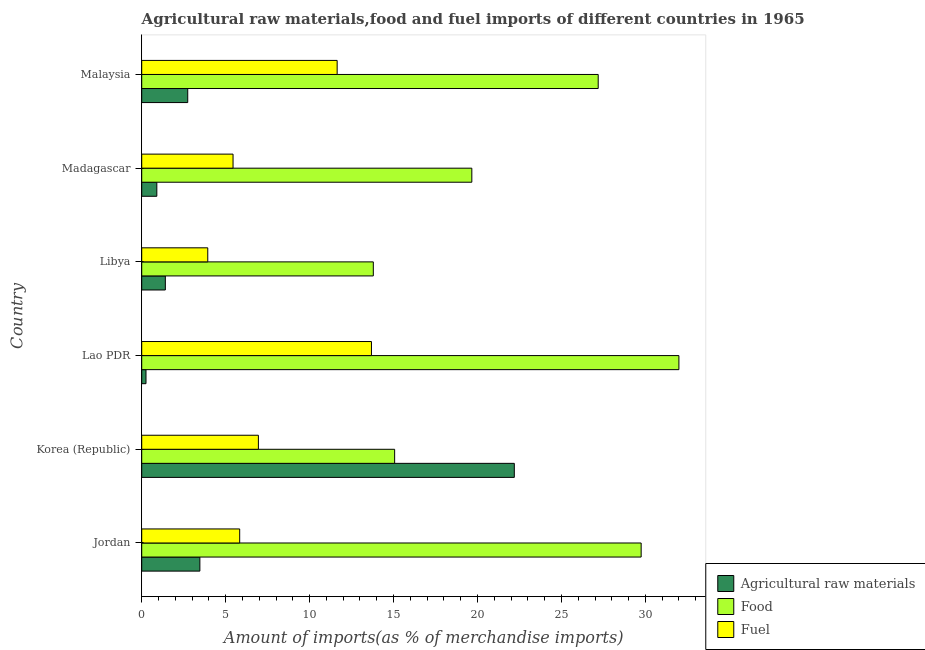How many groups of bars are there?
Ensure brevity in your answer.  6. Are the number of bars per tick equal to the number of legend labels?
Your answer should be very brief. Yes. How many bars are there on the 5th tick from the bottom?
Keep it short and to the point. 3. What is the label of the 3rd group of bars from the top?
Provide a short and direct response. Libya. In how many cases, is the number of bars for a given country not equal to the number of legend labels?
Your response must be concise. 0. What is the percentage of fuel imports in Malaysia?
Your answer should be compact. 11.64. Across all countries, what is the maximum percentage of food imports?
Your answer should be compact. 32. Across all countries, what is the minimum percentage of raw materials imports?
Your answer should be compact. 0.25. In which country was the percentage of food imports maximum?
Keep it short and to the point. Lao PDR. In which country was the percentage of fuel imports minimum?
Ensure brevity in your answer.  Libya. What is the total percentage of fuel imports in the graph?
Keep it short and to the point. 47.48. What is the difference between the percentage of food imports in Jordan and that in Madagascar?
Offer a terse response. 10.09. What is the difference between the percentage of food imports in Madagascar and the percentage of fuel imports in Jordan?
Make the answer very short. 13.83. What is the average percentage of raw materials imports per country?
Provide a succinct answer. 5.16. What is the difference between the percentage of fuel imports and percentage of food imports in Lao PDR?
Provide a short and direct response. -18.31. In how many countries, is the percentage of fuel imports greater than 31 %?
Your response must be concise. 0. What is the ratio of the percentage of food imports in Jordan to that in Korea (Republic)?
Offer a terse response. 1.98. Is the percentage of fuel imports in Madagascar less than that in Malaysia?
Your response must be concise. Yes. What is the difference between the highest and the second highest percentage of raw materials imports?
Offer a very short reply. 18.73. What does the 3rd bar from the top in Madagascar represents?
Provide a succinct answer. Agricultural raw materials. What does the 3rd bar from the bottom in Korea (Republic) represents?
Offer a very short reply. Fuel. Are all the bars in the graph horizontal?
Your answer should be very brief. Yes. What is the difference between two consecutive major ticks on the X-axis?
Provide a succinct answer. 5. Does the graph contain grids?
Keep it short and to the point. No. How many legend labels are there?
Offer a terse response. 3. What is the title of the graph?
Provide a succinct answer. Agricultural raw materials,food and fuel imports of different countries in 1965. What is the label or title of the X-axis?
Provide a short and direct response. Amount of imports(as % of merchandise imports). What is the label or title of the Y-axis?
Make the answer very short. Country. What is the Amount of imports(as % of merchandise imports) of Agricultural raw materials in Jordan?
Ensure brevity in your answer.  3.46. What is the Amount of imports(as % of merchandise imports) in Food in Jordan?
Ensure brevity in your answer.  29.75. What is the Amount of imports(as % of merchandise imports) in Fuel in Jordan?
Make the answer very short. 5.83. What is the Amount of imports(as % of merchandise imports) of Agricultural raw materials in Korea (Republic)?
Give a very brief answer. 22.19. What is the Amount of imports(as % of merchandise imports) of Food in Korea (Republic)?
Keep it short and to the point. 15.06. What is the Amount of imports(as % of merchandise imports) in Fuel in Korea (Republic)?
Offer a very short reply. 6.95. What is the Amount of imports(as % of merchandise imports) in Agricultural raw materials in Lao PDR?
Provide a short and direct response. 0.25. What is the Amount of imports(as % of merchandise imports) of Food in Lao PDR?
Keep it short and to the point. 32. What is the Amount of imports(as % of merchandise imports) of Fuel in Lao PDR?
Offer a terse response. 13.68. What is the Amount of imports(as % of merchandise imports) of Agricultural raw materials in Libya?
Make the answer very short. 1.41. What is the Amount of imports(as % of merchandise imports) of Food in Libya?
Offer a very short reply. 13.79. What is the Amount of imports(as % of merchandise imports) in Fuel in Libya?
Offer a very short reply. 3.93. What is the Amount of imports(as % of merchandise imports) of Agricultural raw materials in Madagascar?
Offer a very short reply. 0.9. What is the Amount of imports(as % of merchandise imports) in Food in Madagascar?
Offer a terse response. 19.66. What is the Amount of imports(as % of merchandise imports) in Fuel in Madagascar?
Your answer should be very brief. 5.44. What is the Amount of imports(as % of merchandise imports) of Agricultural raw materials in Malaysia?
Give a very brief answer. 2.74. What is the Amount of imports(as % of merchandise imports) of Food in Malaysia?
Your response must be concise. 27.19. What is the Amount of imports(as % of merchandise imports) in Fuel in Malaysia?
Ensure brevity in your answer.  11.64. Across all countries, what is the maximum Amount of imports(as % of merchandise imports) in Agricultural raw materials?
Offer a terse response. 22.19. Across all countries, what is the maximum Amount of imports(as % of merchandise imports) of Food?
Provide a succinct answer. 32. Across all countries, what is the maximum Amount of imports(as % of merchandise imports) in Fuel?
Your answer should be compact. 13.68. Across all countries, what is the minimum Amount of imports(as % of merchandise imports) of Agricultural raw materials?
Offer a very short reply. 0.25. Across all countries, what is the minimum Amount of imports(as % of merchandise imports) in Food?
Make the answer very short. 13.79. Across all countries, what is the minimum Amount of imports(as % of merchandise imports) of Fuel?
Make the answer very short. 3.93. What is the total Amount of imports(as % of merchandise imports) in Agricultural raw materials in the graph?
Provide a succinct answer. 30.96. What is the total Amount of imports(as % of merchandise imports) of Food in the graph?
Your answer should be very brief. 137.46. What is the total Amount of imports(as % of merchandise imports) in Fuel in the graph?
Make the answer very short. 47.48. What is the difference between the Amount of imports(as % of merchandise imports) in Agricultural raw materials in Jordan and that in Korea (Republic)?
Offer a terse response. -18.73. What is the difference between the Amount of imports(as % of merchandise imports) in Food in Jordan and that in Korea (Republic)?
Your answer should be compact. 14.68. What is the difference between the Amount of imports(as % of merchandise imports) in Fuel in Jordan and that in Korea (Republic)?
Ensure brevity in your answer.  -1.11. What is the difference between the Amount of imports(as % of merchandise imports) in Agricultural raw materials in Jordan and that in Lao PDR?
Offer a very short reply. 3.21. What is the difference between the Amount of imports(as % of merchandise imports) of Food in Jordan and that in Lao PDR?
Keep it short and to the point. -2.25. What is the difference between the Amount of imports(as % of merchandise imports) of Fuel in Jordan and that in Lao PDR?
Your answer should be compact. -7.85. What is the difference between the Amount of imports(as % of merchandise imports) of Agricultural raw materials in Jordan and that in Libya?
Offer a very short reply. 2.06. What is the difference between the Amount of imports(as % of merchandise imports) in Food in Jordan and that in Libya?
Provide a short and direct response. 15.95. What is the difference between the Amount of imports(as % of merchandise imports) in Fuel in Jordan and that in Libya?
Offer a very short reply. 1.9. What is the difference between the Amount of imports(as % of merchandise imports) of Agricultural raw materials in Jordan and that in Madagascar?
Ensure brevity in your answer.  2.56. What is the difference between the Amount of imports(as % of merchandise imports) in Food in Jordan and that in Madagascar?
Make the answer very short. 10.09. What is the difference between the Amount of imports(as % of merchandise imports) of Fuel in Jordan and that in Madagascar?
Keep it short and to the point. 0.4. What is the difference between the Amount of imports(as % of merchandise imports) of Agricultural raw materials in Jordan and that in Malaysia?
Your answer should be compact. 0.72. What is the difference between the Amount of imports(as % of merchandise imports) in Food in Jordan and that in Malaysia?
Give a very brief answer. 2.56. What is the difference between the Amount of imports(as % of merchandise imports) in Fuel in Jordan and that in Malaysia?
Offer a very short reply. -5.81. What is the difference between the Amount of imports(as % of merchandise imports) in Agricultural raw materials in Korea (Republic) and that in Lao PDR?
Your response must be concise. 21.94. What is the difference between the Amount of imports(as % of merchandise imports) of Food in Korea (Republic) and that in Lao PDR?
Ensure brevity in your answer.  -16.93. What is the difference between the Amount of imports(as % of merchandise imports) of Fuel in Korea (Republic) and that in Lao PDR?
Offer a terse response. -6.73. What is the difference between the Amount of imports(as % of merchandise imports) of Agricultural raw materials in Korea (Republic) and that in Libya?
Make the answer very short. 20.79. What is the difference between the Amount of imports(as % of merchandise imports) of Food in Korea (Republic) and that in Libya?
Your response must be concise. 1.27. What is the difference between the Amount of imports(as % of merchandise imports) of Fuel in Korea (Republic) and that in Libya?
Your response must be concise. 3.02. What is the difference between the Amount of imports(as % of merchandise imports) in Agricultural raw materials in Korea (Republic) and that in Madagascar?
Give a very brief answer. 21.29. What is the difference between the Amount of imports(as % of merchandise imports) of Food in Korea (Republic) and that in Madagascar?
Give a very brief answer. -4.6. What is the difference between the Amount of imports(as % of merchandise imports) of Fuel in Korea (Republic) and that in Madagascar?
Give a very brief answer. 1.51. What is the difference between the Amount of imports(as % of merchandise imports) in Agricultural raw materials in Korea (Republic) and that in Malaysia?
Keep it short and to the point. 19.45. What is the difference between the Amount of imports(as % of merchandise imports) in Food in Korea (Republic) and that in Malaysia?
Provide a short and direct response. -12.13. What is the difference between the Amount of imports(as % of merchandise imports) in Fuel in Korea (Republic) and that in Malaysia?
Offer a terse response. -4.69. What is the difference between the Amount of imports(as % of merchandise imports) of Agricultural raw materials in Lao PDR and that in Libya?
Keep it short and to the point. -1.15. What is the difference between the Amount of imports(as % of merchandise imports) in Food in Lao PDR and that in Libya?
Make the answer very short. 18.2. What is the difference between the Amount of imports(as % of merchandise imports) in Fuel in Lao PDR and that in Libya?
Ensure brevity in your answer.  9.75. What is the difference between the Amount of imports(as % of merchandise imports) of Agricultural raw materials in Lao PDR and that in Madagascar?
Provide a succinct answer. -0.64. What is the difference between the Amount of imports(as % of merchandise imports) in Food in Lao PDR and that in Madagascar?
Give a very brief answer. 12.33. What is the difference between the Amount of imports(as % of merchandise imports) of Fuel in Lao PDR and that in Madagascar?
Keep it short and to the point. 8.24. What is the difference between the Amount of imports(as % of merchandise imports) of Agricultural raw materials in Lao PDR and that in Malaysia?
Your response must be concise. -2.49. What is the difference between the Amount of imports(as % of merchandise imports) in Food in Lao PDR and that in Malaysia?
Your answer should be very brief. 4.81. What is the difference between the Amount of imports(as % of merchandise imports) of Fuel in Lao PDR and that in Malaysia?
Give a very brief answer. 2.04. What is the difference between the Amount of imports(as % of merchandise imports) in Agricultural raw materials in Libya and that in Madagascar?
Offer a terse response. 0.51. What is the difference between the Amount of imports(as % of merchandise imports) in Food in Libya and that in Madagascar?
Offer a terse response. -5.87. What is the difference between the Amount of imports(as % of merchandise imports) of Fuel in Libya and that in Madagascar?
Your response must be concise. -1.51. What is the difference between the Amount of imports(as % of merchandise imports) of Agricultural raw materials in Libya and that in Malaysia?
Your response must be concise. -1.33. What is the difference between the Amount of imports(as % of merchandise imports) in Food in Libya and that in Malaysia?
Offer a terse response. -13.4. What is the difference between the Amount of imports(as % of merchandise imports) of Fuel in Libya and that in Malaysia?
Make the answer very short. -7.71. What is the difference between the Amount of imports(as % of merchandise imports) in Agricultural raw materials in Madagascar and that in Malaysia?
Provide a short and direct response. -1.84. What is the difference between the Amount of imports(as % of merchandise imports) of Food in Madagascar and that in Malaysia?
Keep it short and to the point. -7.53. What is the difference between the Amount of imports(as % of merchandise imports) of Fuel in Madagascar and that in Malaysia?
Offer a very short reply. -6.2. What is the difference between the Amount of imports(as % of merchandise imports) of Agricultural raw materials in Jordan and the Amount of imports(as % of merchandise imports) of Food in Korea (Republic)?
Keep it short and to the point. -11.6. What is the difference between the Amount of imports(as % of merchandise imports) of Agricultural raw materials in Jordan and the Amount of imports(as % of merchandise imports) of Fuel in Korea (Republic)?
Your answer should be very brief. -3.49. What is the difference between the Amount of imports(as % of merchandise imports) in Food in Jordan and the Amount of imports(as % of merchandise imports) in Fuel in Korea (Republic)?
Give a very brief answer. 22.8. What is the difference between the Amount of imports(as % of merchandise imports) of Agricultural raw materials in Jordan and the Amount of imports(as % of merchandise imports) of Food in Lao PDR?
Your answer should be compact. -28.53. What is the difference between the Amount of imports(as % of merchandise imports) of Agricultural raw materials in Jordan and the Amount of imports(as % of merchandise imports) of Fuel in Lao PDR?
Your answer should be compact. -10.22. What is the difference between the Amount of imports(as % of merchandise imports) of Food in Jordan and the Amount of imports(as % of merchandise imports) of Fuel in Lao PDR?
Offer a very short reply. 16.06. What is the difference between the Amount of imports(as % of merchandise imports) in Agricultural raw materials in Jordan and the Amount of imports(as % of merchandise imports) in Food in Libya?
Ensure brevity in your answer.  -10.33. What is the difference between the Amount of imports(as % of merchandise imports) of Agricultural raw materials in Jordan and the Amount of imports(as % of merchandise imports) of Fuel in Libya?
Make the answer very short. -0.47. What is the difference between the Amount of imports(as % of merchandise imports) in Food in Jordan and the Amount of imports(as % of merchandise imports) in Fuel in Libya?
Provide a short and direct response. 25.81. What is the difference between the Amount of imports(as % of merchandise imports) of Agricultural raw materials in Jordan and the Amount of imports(as % of merchandise imports) of Food in Madagascar?
Make the answer very short. -16.2. What is the difference between the Amount of imports(as % of merchandise imports) in Agricultural raw materials in Jordan and the Amount of imports(as % of merchandise imports) in Fuel in Madagascar?
Offer a terse response. -1.98. What is the difference between the Amount of imports(as % of merchandise imports) of Food in Jordan and the Amount of imports(as % of merchandise imports) of Fuel in Madagascar?
Provide a short and direct response. 24.31. What is the difference between the Amount of imports(as % of merchandise imports) of Agricultural raw materials in Jordan and the Amount of imports(as % of merchandise imports) of Food in Malaysia?
Keep it short and to the point. -23.73. What is the difference between the Amount of imports(as % of merchandise imports) of Agricultural raw materials in Jordan and the Amount of imports(as % of merchandise imports) of Fuel in Malaysia?
Your answer should be very brief. -8.18. What is the difference between the Amount of imports(as % of merchandise imports) of Food in Jordan and the Amount of imports(as % of merchandise imports) of Fuel in Malaysia?
Give a very brief answer. 18.11. What is the difference between the Amount of imports(as % of merchandise imports) of Agricultural raw materials in Korea (Republic) and the Amount of imports(as % of merchandise imports) of Food in Lao PDR?
Your answer should be very brief. -9.8. What is the difference between the Amount of imports(as % of merchandise imports) in Agricultural raw materials in Korea (Republic) and the Amount of imports(as % of merchandise imports) in Fuel in Lao PDR?
Keep it short and to the point. 8.51. What is the difference between the Amount of imports(as % of merchandise imports) of Food in Korea (Republic) and the Amount of imports(as % of merchandise imports) of Fuel in Lao PDR?
Offer a terse response. 1.38. What is the difference between the Amount of imports(as % of merchandise imports) in Agricultural raw materials in Korea (Republic) and the Amount of imports(as % of merchandise imports) in Food in Libya?
Ensure brevity in your answer.  8.4. What is the difference between the Amount of imports(as % of merchandise imports) in Agricultural raw materials in Korea (Republic) and the Amount of imports(as % of merchandise imports) in Fuel in Libya?
Make the answer very short. 18.26. What is the difference between the Amount of imports(as % of merchandise imports) of Food in Korea (Republic) and the Amount of imports(as % of merchandise imports) of Fuel in Libya?
Ensure brevity in your answer.  11.13. What is the difference between the Amount of imports(as % of merchandise imports) of Agricultural raw materials in Korea (Republic) and the Amount of imports(as % of merchandise imports) of Food in Madagascar?
Your response must be concise. 2.53. What is the difference between the Amount of imports(as % of merchandise imports) of Agricultural raw materials in Korea (Republic) and the Amount of imports(as % of merchandise imports) of Fuel in Madagascar?
Your response must be concise. 16.75. What is the difference between the Amount of imports(as % of merchandise imports) in Food in Korea (Republic) and the Amount of imports(as % of merchandise imports) in Fuel in Madagascar?
Provide a short and direct response. 9.63. What is the difference between the Amount of imports(as % of merchandise imports) in Agricultural raw materials in Korea (Republic) and the Amount of imports(as % of merchandise imports) in Food in Malaysia?
Give a very brief answer. -5. What is the difference between the Amount of imports(as % of merchandise imports) of Agricultural raw materials in Korea (Republic) and the Amount of imports(as % of merchandise imports) of Fuel in Malaysia?
Ensure brevity in your answer.  10.55. What is the difference between the Amount of imports(as % of merchandise imports) of Food in Korea (Republic) and the Amount of imports(as % of merchandise imports) of Fuel in Malaysia?
Make the answer very short. 3.42. What is the difference between the Amount of imports(as % of merchandise imports) in Agricultural raw materials in Lao PDR and the Amount of imports(as % of merchandise imports) in Food in Libya?
Your response must be concise. -13.54. What is the difference between the Amount of imports(as % of merchandise imports) of Agricultural raw materials in Lao PDR and the Amount of imports(as % of merchandise imports) of Fuel in Libya?
Offer a very short reply. -3.68. What is the difference between the Amount of imports(as % of merchandise imports) of Food in Lao PDR and the Amount of imports(as % of merchandise imports) of Fuel in Libya?
Keep it short and to the point. 28.06. What is the difference between the Amount of imports(as % of merchandise imports) in Agricultural raw materials in Lao PDR and the Amount of imports(as % of merchandise imports) in Food in Madagascar?
Your answer should be compact. -19.41. What is the difference between the Amount of imports(as % of merchandise imports) in Agricultural raw materials in Lao PDR and the Amount of imports(as % of merchandise imports) in Fuel in Madagascar?
Your answer should be compact. -5.18. What is the difference between the Amount of imports(as % of merchandise imports) of Food in Lao PDR and the Amount of imports(as % of merchandise imports) of Fuel in Madagascar?
Keep it short and to the point. 26.56. What is the difference between the Amount of imports(as % of merchandise imports) of Agricultural raw materials in Lao PDR and the Amount of imports(as % of merchandise imports) of Food in Malaysia?
Your answer should be very brief. -26.93. What is the difference between the Amount of imports(as % of merchandise imports) of Agricultural raw materials in Lao PDR and the Amount of imports(as % of merchandise imports) of Fuel in Malaysia?
Provide a short and direct response. -11.39. What is the difference between the Amount of imports(as % of merchandise imports) in Food in Lao PDR and the Amount of imports(as % of merchandise imports) in Fuel in Malaysia?
Your response must be concise. 20.36. What is the difference between the Amount of imports(as % of merchandise imports) of Agricultural raw materials in Libya and the Amount of imports(as % of merchandise imports) of Food in Madagascar?
Keep it short and to the point. -18.26. What is the difference between the Amount of imports(as % of merchandise imports) in Agricultural raw materials in Libya and the Amount of imports(as % of merchandise imports) in Fuel in Madagascar?
Make the answer very short. -4.03. What is the difference between the Amount of imports(as % of merchandise imports) in Food in Libya and the Amount of imports(as % of merchandise imports) in Fuel in Madagascar?
Your response must be concise. 8.35. What is the difference between the Amount of imports(as % of merchandise imports) in Agricultural raw materials in Libya and the Amount of imports(as % of merchandise imports) in Food in Malaysia?
Ensure brevity in your answer.  -25.78. What is the difference between the Amount of imports(as % of merchandise imports) in Agricultural raw materials in Libya and the Amount of imports(as % of merchandise imports) in Fuel in Malaysia?
Make the answer very short. -10.23. What is the difference between the Amount of imports(as % of merchandise imports) in Food in Libya and the Amount of imports(as % of merchandise imports) in Fuel in Malaysia?
Make the answer very short. 2.15. What is the difference between the Amount of imports(as % of merchandise imports) in Agricultural raw materials in Madagascar and the Amount of imports(as % of merchandise imports) in Food in Malaysia?
Provide a short and direct response. -26.29. What is the difference between the Amount of imports(as % of merchandise imports) of Agricultural raw materials in Madagascar and the Amount of imports(as % of merchandise imports) of Fuel in Malaysia?
Provide a short and direct response. -10.74. What is the difference between the Amount of imports(as % of merchandise imports) in Food in Madagascar and the Amount of imports(as % of merchandise imports) in Fuel in Malaysia?
Make the answer very short. 8.02. What is the average Amount of imports(as % of merchandise imports) of Agricultural raw materials per country?
Offer a very short reply. 5.16. What is the average Amount of imports(as % of merchandise imports) in Food per country?
Provide a succinct answer. 22.91. What is the average Amount of imports(as % of merchandise imports) in Fuel per country?
Make the answer very short. 7.91. What is the difference between the Amount of imports(as % of merchandise imports) of Agricultural raw materials and Amount of imports(as % of merchandise imports) of Food in Jordan?
Ensure brevity in your answer.  -26.28. What is the difference between the Amount of imports(as % of merchandise imports) of Agricultural raw materials and Amount of imports(as % of merchandise imports) of Fuel in Jordan?
Offer a terse response. -2.37. What is the difference between the Amount of imports(as % of merchandise imports) in Food and Amount of imports(as % of merchandise imports) in Fuel in Jordan?
Offer a very short reply. 23.91. What is the difference between the Amount of imports(as % of merchandise imports) in Agricultural raw materials and Amount of imports(as % of merchandise imports) in Food in Korea (Republic)?
Give a very brief answer. 7.13. What is the difference between the Amount of imports(as % of merchandise imports) in Agricultural raw materials and Amount of imports(as % of merchandise imports) in Fuel in Korea (Republic)?
Your response must be concise. 15.24. What is the difference between the Amount of imports(as % of merchandise imports) in Food and Amount of imports(as % of merchandise imports) in Fuel in Korea (Republic)?
Your answer should be compact. 8.12. What is the difference between the Amount of imports(as % of merchandise imports) of Agricultural raw materials and Amount of imports(as % of merchandise imports) of Food in Lao PDR?
Offer a terse response. -31.74. What is the difference between the Amount of imports(as % of merchandise imports) of Agricultural raw materials and Amount of imports(as % of merchandise imports) of Fuel in Lao PDR?
Your answer should be very brief. -13.43. What is the difference between the Amount of imports(as % of merchandise imports) in Food and Amount of imports(as % of merchandise imports) in Fuel in Lao PDR?
Offer a terse response. 18.31. What is the difference between the Amount of imports(as % of merchandise imports) in Agricultural raw materials and Amount of imports(as % of merchandise imports) in Food in Libya?
Offer a very short reply. -12.39. What is the difference between the Amount of imports(as % of merchandise imports) of Agricultural raw materials and Amount of imports(as % of merchandise imports) of Fuel in Libya?
Offer a terse response. -2.53. What is the difference between the Amount of imports(as % of merchandise imports) in Food and Amount of imports(as % of merchandise imports) in Fuel in Libya?
Make the answer very short. 9.86. What is the difference between the Amount of imports(as % of merchandise imports) of Agricultural raw materials and Amount of imports(as % of merchandise imports) of Food in Madagascar?
Your answer should be compact. -18.76. What is the difference between the Amount of imports(as % of merchandise imports) of Agricultural raw materials and Amount of imports(as % of merchandise imports) of Fuel in Madagascar?
Your response must be concise. -4.54. What is the difference between the Amount of imports(as % of merchandise imports) of Food and Amount of imports(as % of merchandise imports) of Fuel in Madagascar?
Provide a succinct answer. 14.22. What is the difference between the Amount of imports(as % of merchandise imports) of Agricultural raw materials and Amount of imports(as % of merchandise imports) of Food in Malaysia?
Make the answer very short. -24.45. What is the difference between the Amount of imports(as % of merchandise imports) of Agricultural raw materials and Amount of imports(as % of merchandise imports) of Fuel in Malaysia?
Keep it short and to the point. -8.9. What is the difference between the Amount of imports(as % of merchandise imports) of Food and Amount of imports(as % of merchandise imports) of Fuel in Malaysia?
Ensure brevity in your answer.  15.55. What is the ratio of the Amount of imports(as % of merchandise imports) of Agricultural raw materials in Jordan to that in Korea (Republic)?
Provide a short and direct response. 0.16. What is the ratio of the Amount of imports(as % of merchandise imports) of Food in Jordan to that in Korea (Republic)?
Provide a short and direct response. 1.97. What is the ratio of the Amount of imports(as % of merchandise imports) in Fuel in Jordan to that in Korea (Republic)?
Ensure brevity in your answer.  0.84. What is the ratio of the Amount of imports(as % of merchandise imports) of Agricultural raw materials in Jordan to that in Lao PDR?
Give a very brief answer. 13.59. What is the ratio of the Amount of imports(as % of merchandise imports) of Food in Jordan to that in Lao PDR?
Provide a short and direct response. 0.93. What is the ratio of the Amount of imports(as % of merchandise imports) of Fuel in Jordan to that in Lao PDR?
Offer a terse response. 0.43. What is the ratio of the Amount of imports(as % of merchandise imports) of Agricultural raw materials in Jordan to that in Libya?
Ensure brevity in your answer.  2.46. What is the ratio of the Amount of imports(as % of merchandise imports) in Food in Jordan to that in Libya?
Ensure brevity in your answer.  2.16. What is the ratio of the Amount of imports(as % of merchandise imports) of Fuel in Jordan to that in Libya?
Provide a succinct answer. 1.48. What is the ratio of the Amount of imports(as % of merchandise imports) of Agricultural raw materials in Jordan to that in Madagascar?
Your answer should be compact. 3.85. What is the ratio of the Amount of imports(as % of merchandise imports) in Food in Jordan to that in Madagascar?
Keep it short and to the point. 1.51. What is the ratio of the Amount of imports(as % of merchandise imports) of Fuel in Jordan to that in Madagascar?
Offer a terse response. 1.07. What is the ratio of the Amount of imports(as % of merchandise imports) of Agricultural raw materials in Jordan to that in Malaysia?
Your answer should be compact. 1.26. What is the ratio of the Amount of imports(as % of merchandise imports) of Food in Jordan to that in Malaysia?
Offer a very short reply. 1.09. What is the ratio of the Amount of imports(as % of merchandise imports) of Fuel in Jordan to that in Malaysia?
Keep it short and to the point. 0.5. What is the ratio of the Amount of imports(as % of merchandise imports) in Agricultural raw materials in Korea (Republic) to that in Lao PDR?
Make the answer very short. 87.07. What is the ratio of the Amount of imports(as % of merchandise imports) of Food in Korea (Republic) to that in Lao PDR?
Ensure brevity in your answer.  0.47. What is the ratio of the Amount of imports(as % of merchandise imports) of Fuel in Korea (Republic) to that in Lao PDR?
Give a very brief answer. 0.51. What is the ratio of the Amount of imports(as % of merchandise imports) in Agricultural raw materials in Korea (Republic) to that in Libya?
Provide a succinct answer. 15.77. What is the ratio of the Amount of imports(as % of merchandise imports) in Food in Korea (Republic) to that in Libya?
Make the answer very short. 1.09. What is the ratio of the Amount of imports(as % of merchandise imports) in Fuel in Korea (Republic) to that in Libya?
Your answer should be very brief. 1.77. What is the ratio of the Amount of imports(as % of merchandise imports) of Agricultural raw materials in Korea (Republic) to that in Madagascar?
Make the answer very short. 24.67. What is the ratio of the Amount of imports(as % of merchandise imports) of Food in Korea (Republic) to that in Madagascar?
Your answer should be very brief. 0.77. What is the ratio of the Amount of imports(as % of merchandise imports) in Fuel in Korea (Republic) to that in Madagascar?
Offer a very short reply. 1.28. What is the ratio of the Amount of imports(as % of merchandise imports) in Agricultural raw materials in Korea (Republic) to that in Malaysia?
Provide a succinct answer. 8.1. What is the ratio of the Amount of imports(as % of merchandise imports) in Food in Korea (Republic) to that in Malaysia?
Provide a succinct answer. 0.55. What is the ratio of the Amount of imports(as % of merchandise imports) of Fuel in Korea (Republic) to that in Malaysia?
Your response must be concise. 0.6. What is the ratio of the Amount of imports(as % of merchandise imports) of Agricultural raw materials in Lao PDR to that in Libya?
Your response must be concise. 0.18. What is the ratio of the Amount of imports(as % of merchandise imports) in Food in Lao PDR to that in Libya?
Your answer should be compact. 2.32. What is the ratio of the Amount of imports(as % of merchandise imports) in Fuel in Lao PDR to that in Libya?
Ensure brevity in your answer.  3.48. What is the ratio of the Amount of imports(as % of merchandise imports) of Agricultural raw materials in Lao PDR to that in Madagascar?
Provide a succinct answer. 0.28. What is the ratio of the Amount of imports(as % of merchandise imports) in Food in Lao PDR to that in Madagascar?
Ensure brevity in your answer.  1.63. What is the ratio of the Amount of imports(as % of merchandise imports) of Fuel in Lao PDR to that in Madagascar?
Your response must be concise. 2.52. What is the ratio of the Amount of imports(as % of merchandise imports) of Agricultural raw materials in Lao PDR to that in Malaysia?
Give a very brief answer. 0.09. What is the ratio of the Amount of imports(as % of merchandise imports) in Food in Lao PDR to that in Malaysia?
Your answer should be compact. 1.18. What is the ratio of the Amount of imports(as % of merchandise imports) of Fuel in Lao PDR to that in Malaysia?
Give a very brief answer. 1.18. What is the ratio of the Amount of imports(as % of merchandise imports) in Agricultural raw materials in Libya to that in Madagascar?
Your response must be concise. 1.56. What is the ratio of the Amount of imports(as % of merchandise imports) in Food in Libya to that in Madagascar?
Your answer should be compact. 0.7. What is the ratio of the Amount of imports(as % of merchandise imports) in Fuel in Libya to that in Madagascar?
Offer a very short reply. 0.72. What is the ratio of the Amount of imports(as % of merchandise imports) of Agricultural raw materials in Libya to that in Malaysia?
Offer a terse response. 0.51. What is the ratio of the Amount of imports(as % of merchandise imports) of Food in Libya to that in Malaysia?
Provide a short and direct response. 0.51. What is the ratio of the Amount of imports(as % of merchandise imports) in Fuel in Libya to that in Malaysia?
Your response must be concise. 0.34. What is the ratio of the Amount of imports(as % of merchandise imports) of Agricultural raw materials in Madagascar to that in Malaysia?
Your answer should be compact. 0.33. What is the ratio of the Amount of imports(as % of merchandise imports) in Food in Madagascar to that in Malaysia?
Your response must be concise. 0.72. What is the ratio of the Amount of imports(as % of merchandise imports) of Fuel in Madagascar to that in Malaysia?
Provide a succinct answer. 0.47. What is the difference between the highest and the second highest Amount of imports(as % of merchandise imports) in Agricultural raw materials?
Give a very brief answer. 18.73. What is the difference between the highest and the second highest Amount of imports(as % of merchandise imports) of Food?
Provide a succinct answer. 2.25. What is the difference between the highest and the second highest Amount of imports(as % of merchandise imports) in Fuel?
Offer a terse response. 2.04. What is the difference between the highest and the lowest Amount of imports(as % of merchandise imports) in Agricultural raw materials?
Make the answer very short. 21.94. What is the difference between the highest and the lowest Amount of imports(as % of merchandise imports) in Food?
Your response must be concise. 18.2. What is the difference between the highest and the lowest Amount of imports(as % of merchandise imports) of Fuel?
Make the answer very short. 9.75. 